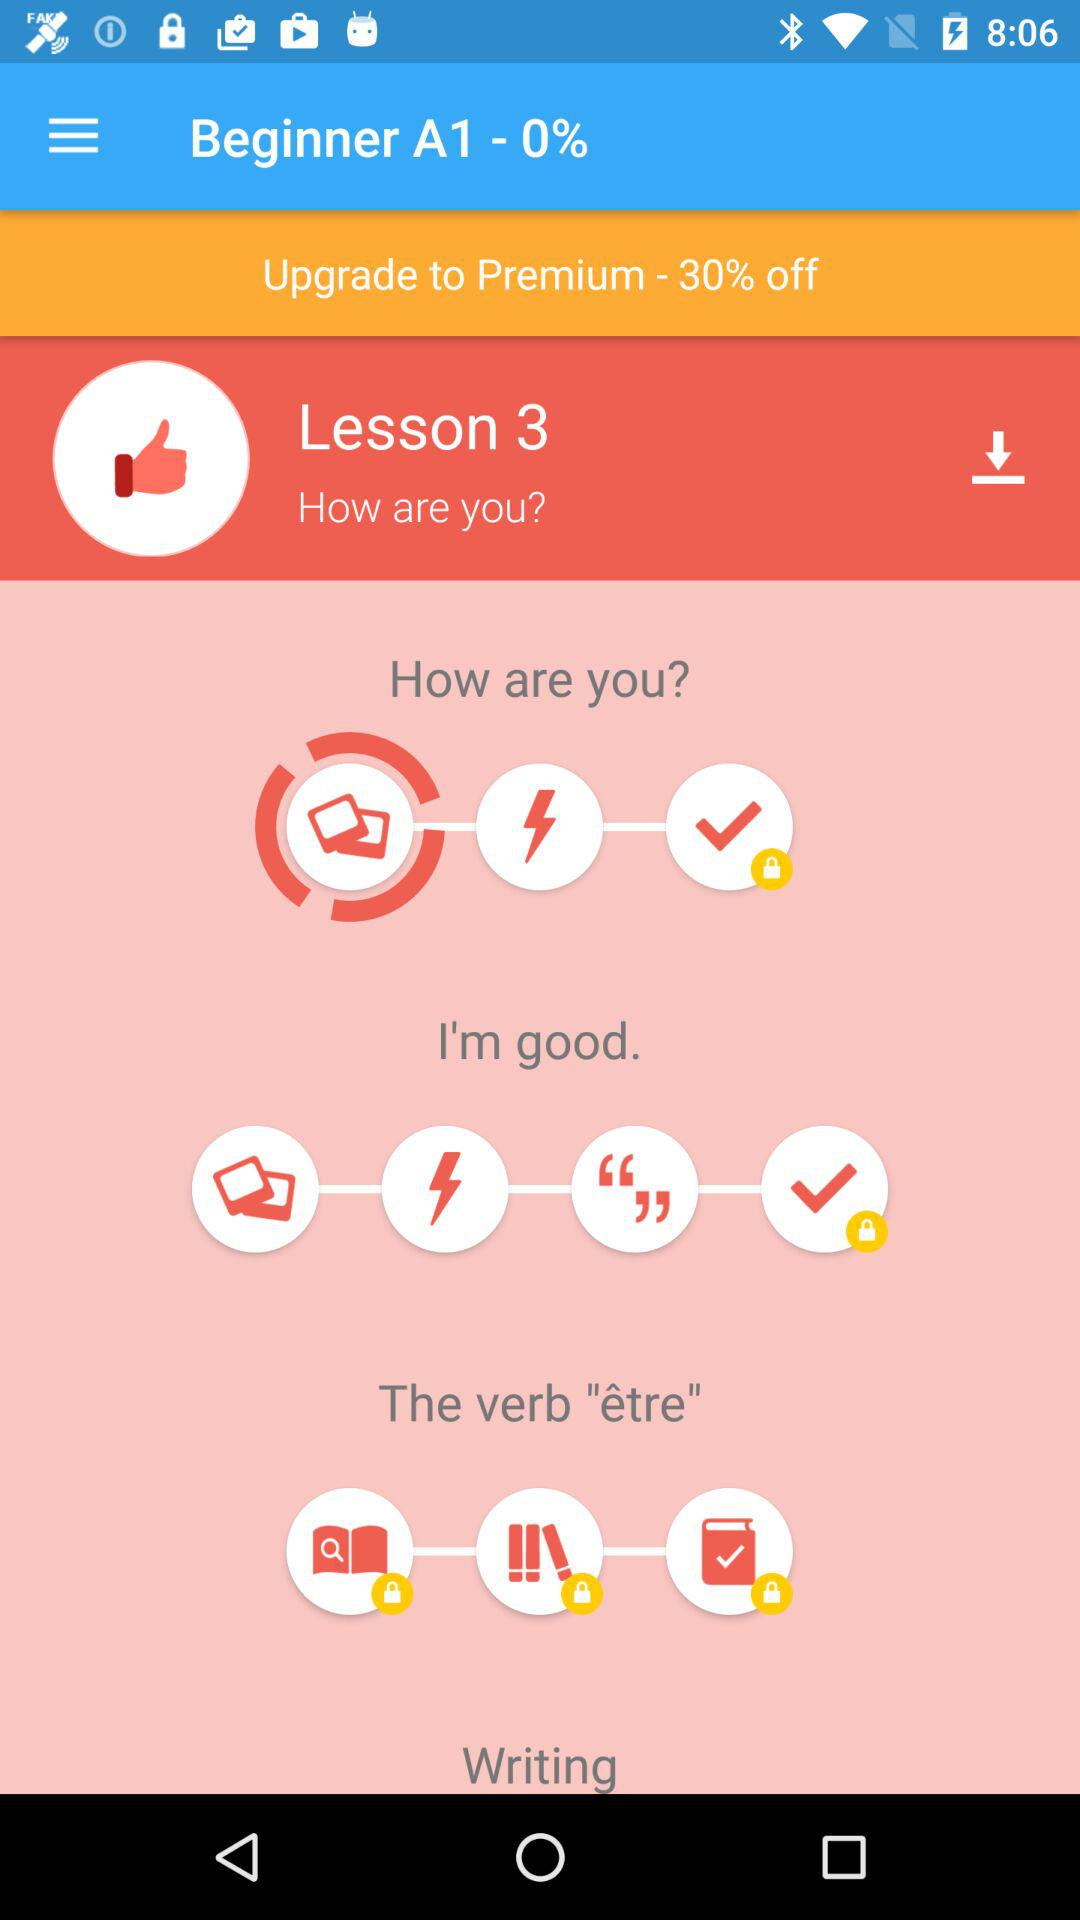What kind of learning features does the app offer for this lesson? The app provides a variety of interactive learning features for this lesson. As shown in the image, there are icons for practicing speaking, listening, and writing, as well as assessment checks to measure understanding. Each icon likely represents a different activity or component of the lesson designed to engage different aspects of language learning. 